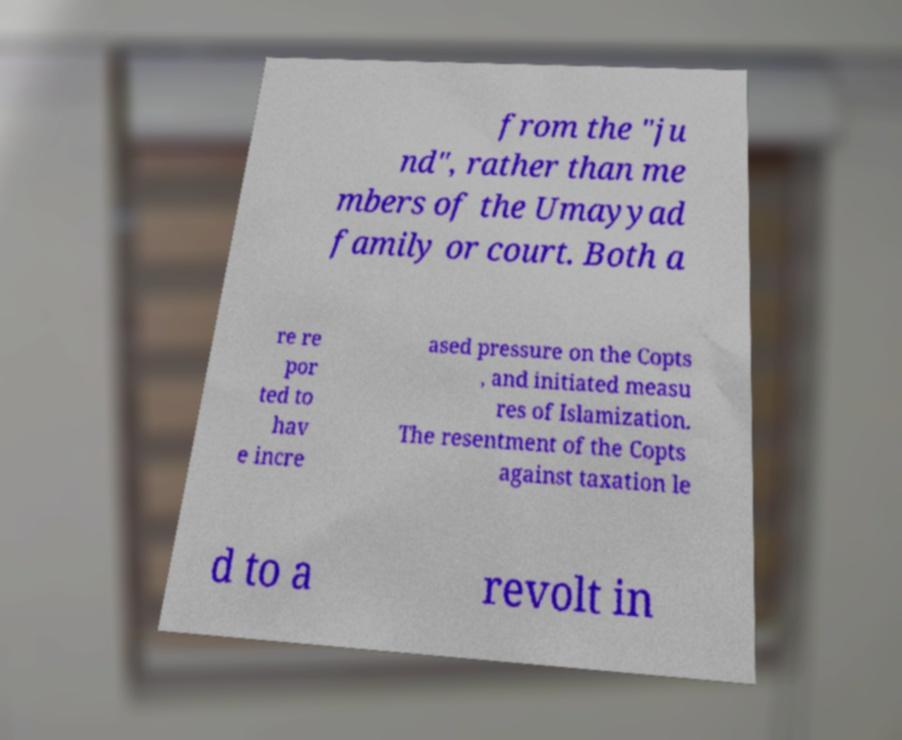What messages or text are displayed in this image? I need them in a readable, typed format. from the "ju nd", rather than me mbers of the Umayyad family or court. Both a re re por ted to hav e incre ased pressure on the Copts , and initiated measu res of Islamization. The resentment of the Copts against taxation le d to a revolt in 